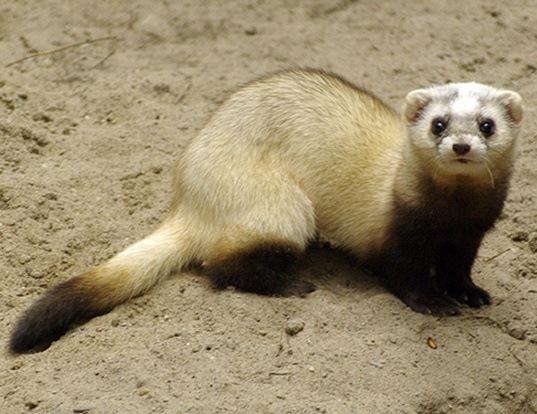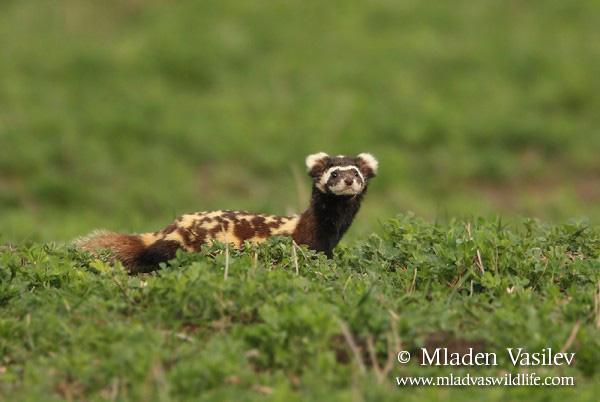The first image is the image on the left, the second image is the image on the right. For the images shown, is this caption "The right image features one ferret with spotted fur and a tail that curves inward over its back, and the left image features an animal with its front paws on a rock and its body turned rightward." true? Answer yes or no. No. The first image is the image on the left, the second image is the image on the right. Considering the images on both sides, is "The left and right image contains the same number of mustelids facing opposite directions." valid? Answer yes or no. No. 